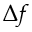<formula> <loc_0><loc_0><loc_500><loc_500>\Delta f</formula> 